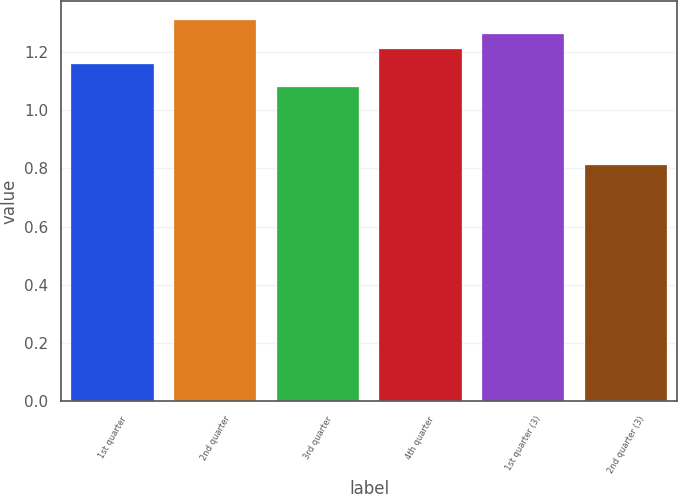Convert chart to OTSL. <chart><loc_0><loc_0><loc_500><loc_500><bar_chart><fcel>1st quarter<fcel>2nd quarter<fcel>3rd quarter<fcel>4th quarter<fcel>1st quarter (3)<fcel>2nd quarter (3)<nl><fcel>1.16<fcel>1.31<fcel>1.08<fcel>1.21<fcel>1.26<fcel>0.81<nl></chart> 